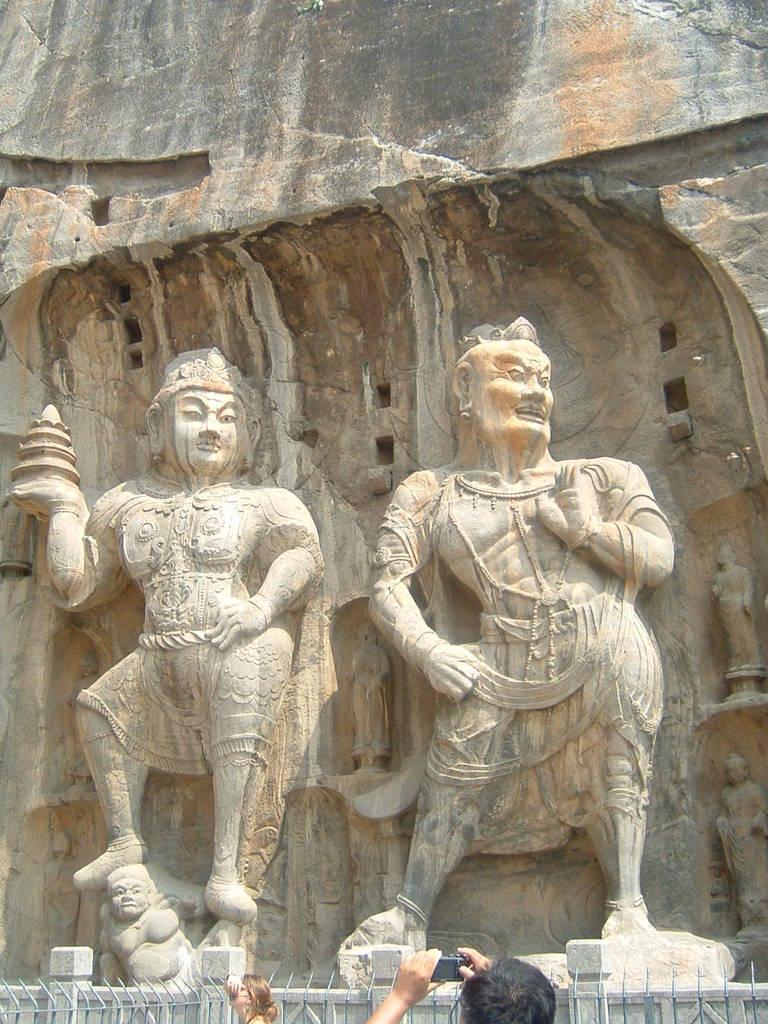Describe this image in one or two sentences. In this image I can see three sculptures. On the bottom side of the image I can see two persons, the iron fence, the wall and I can see one person is holding a camera. 